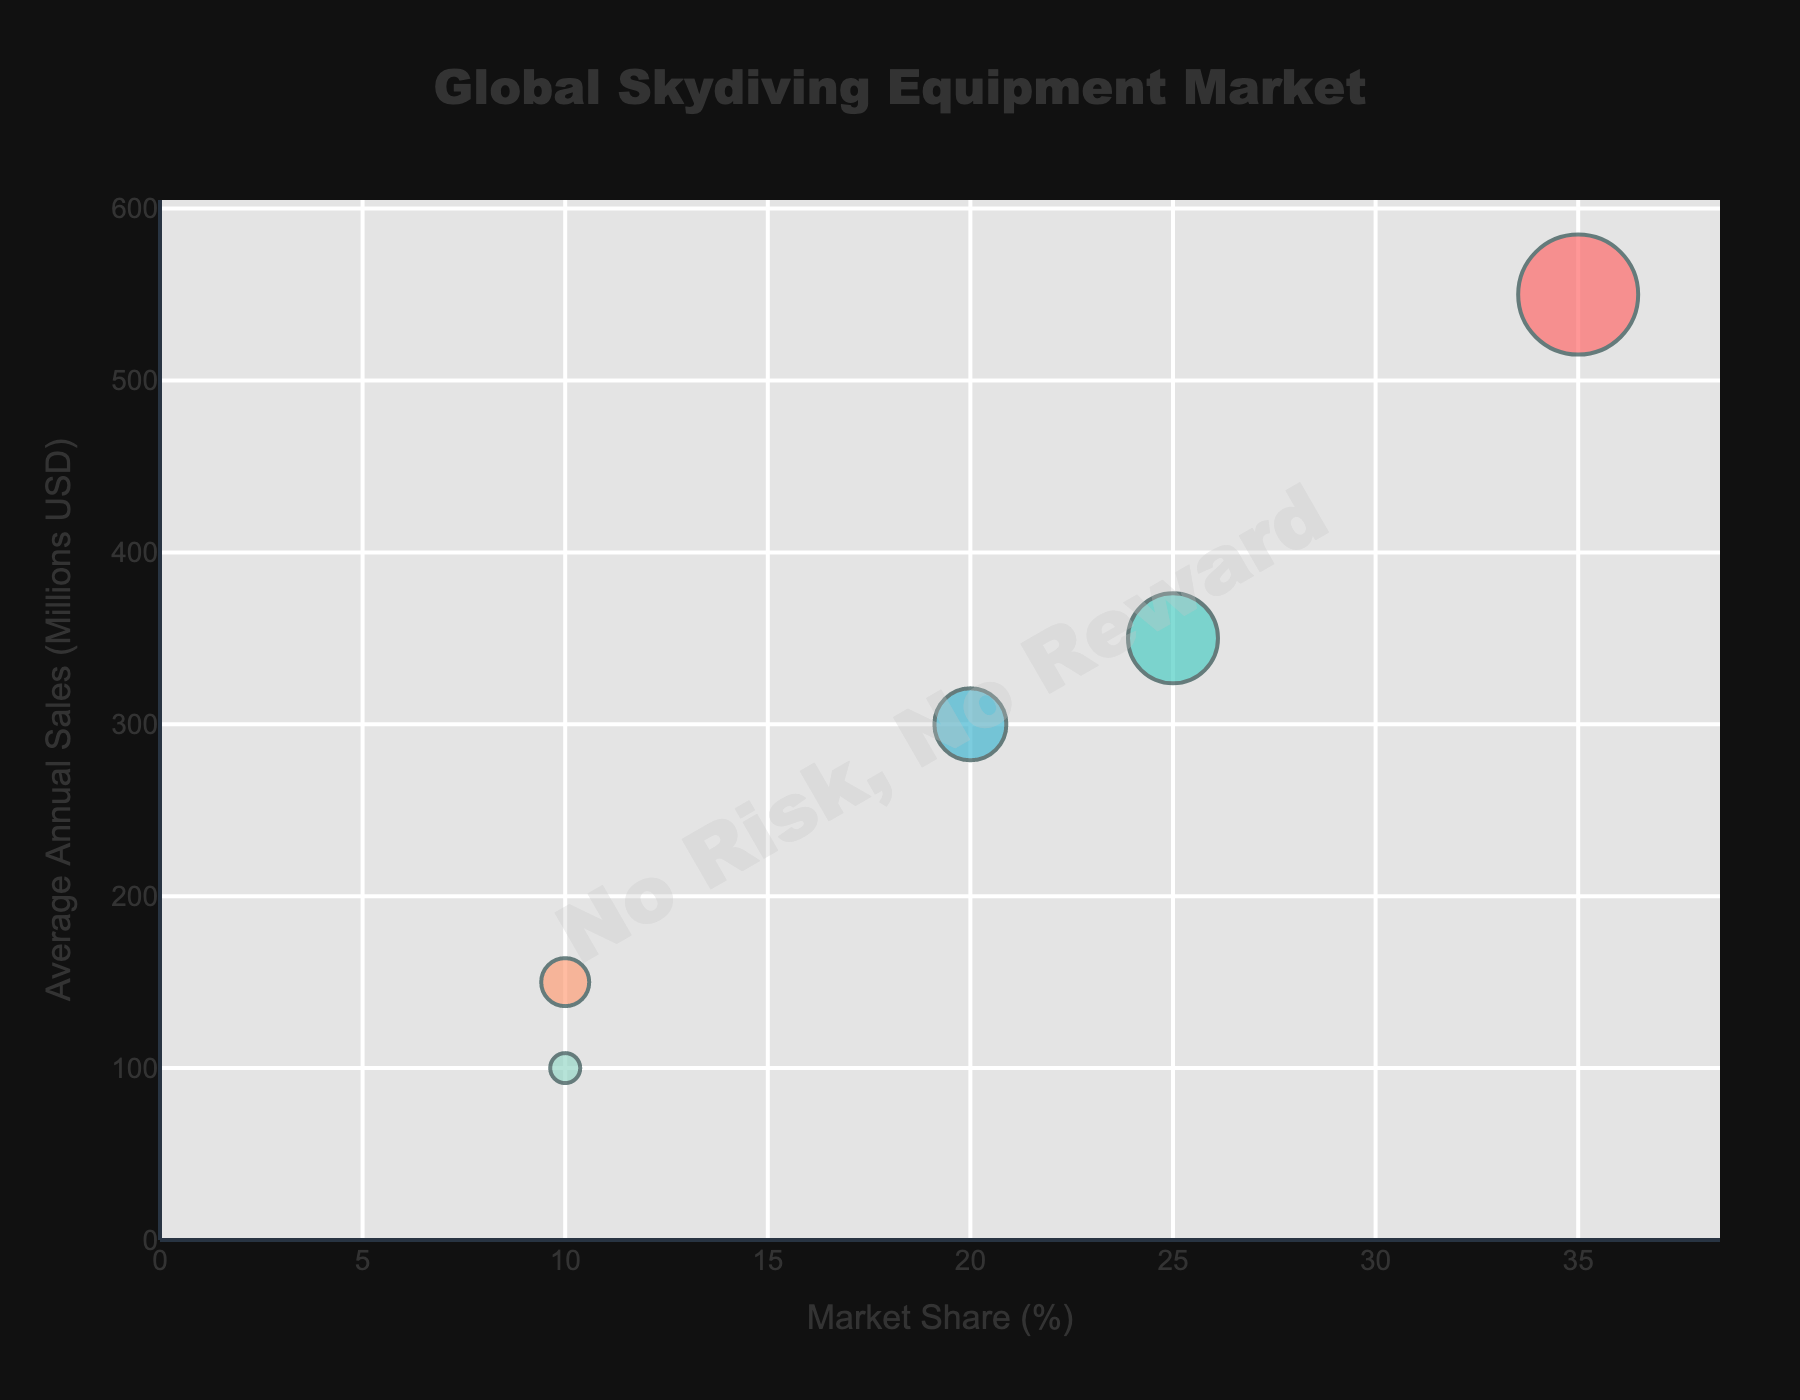How many regions have a market share of 10%? By looking at the x-axis labeled "Market Share (%)", we can see two regions (Latin America and Middle East & Africa) share 10%. They both line up at the 10% mark.
Answer: 2 Which region has the highest average annual sales? The y-axis represents "Average Annual Sales (Millions USD)", and the region with the highest value is North America at 550 million dollars.
Answer: North America What are the average annual sales for Europe and Asia-Pacific combined? From the y-axis, Europe has 350 million and Asia-Pacific has 300 million in annual sales. Adding these values: 350 + 300 = 650 million dollars.
Answer: 650 million dollars Which region has the least number of manufacturers? The size of the bubbles is proportional to the number of manufacturers. The smallest bubble represents the Middle East & Africa with 5 manufacturers.
Answer: Middle East & Africa How does the market share of North America compare to Europe? North America's market share is 35%, and Europe's is 25%. By comparing the two values, North America has a greater market share by 10 percentage points.
Answer: North America by 10 percentage points What is the total number of manufacturers among all regions? Summing up the number of manufacturers: 20 (North America) + 15 (Europe) + 12 (Asia-Pacific) + 8 (Latin America) + 5 (Middle East & Africa) = 60 manufacturers in total.
Answer: 60 manufacturers What colors correspond to the regions in the bubble chart? Observing the colors in the figure: North America is represented by red, Europe by teal, Asia-Pacific by blue, Latin America by orange, and Middle East & Africa by mint green.
Answer: North America - Red, Europe - Teal, Asia-Pacific - Blue, Latin America - Orange, Middle East & Africa - Mint Green If the market share of Latin America increases by 5%, what would the new total market share be for all regions combined? The initial total market share is 100%. Adding 5% to Latin America's current 10% would only change the distribution among regions, not the total. The total market share will still be 100%.
Answer: 100% Which region has a market share that is equal to the combined market share of the Middle East & Africa and Latin America? The combined market share of Middle East & Africa (10%) and Latin America (10%) is 20%. Asia-Pacific has a market share equal to 20%.
Answer: Asia-Pacific 